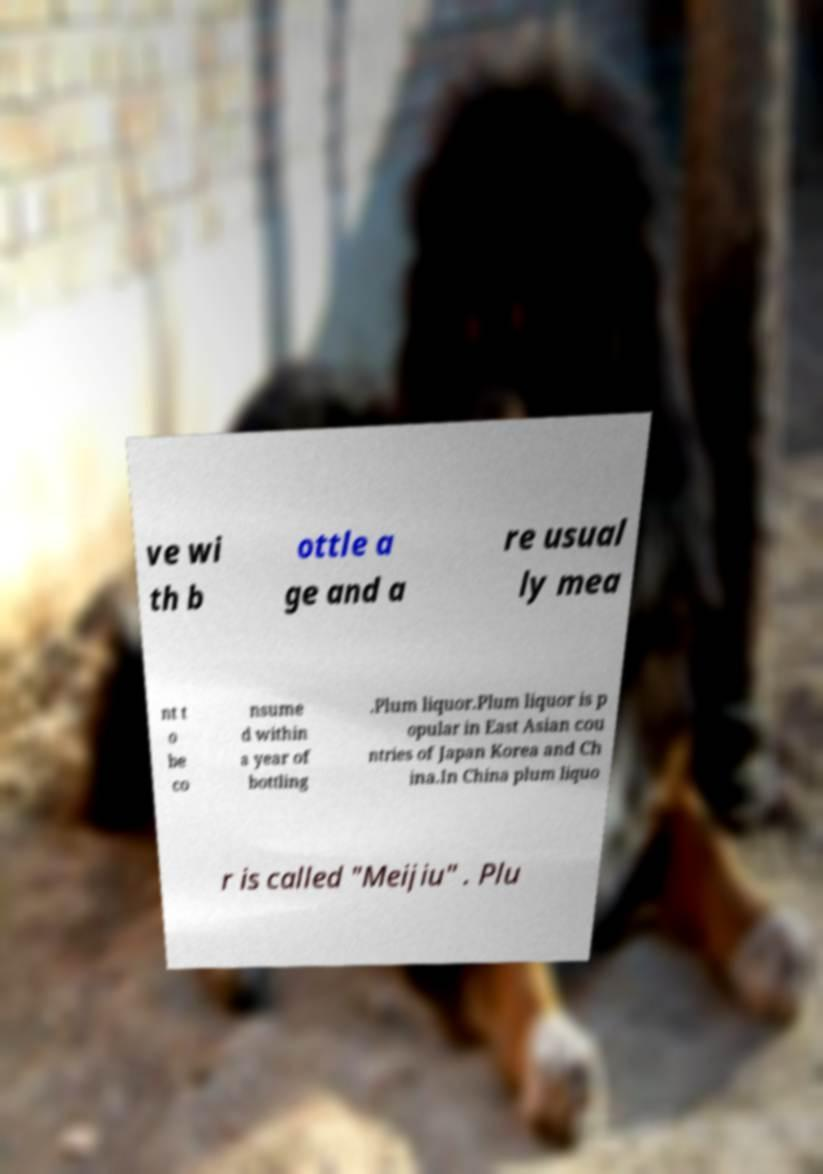Can you accurately transcribe the text from the provided image for me? ve wi th b ottle a ge and a re usual ly mea nt t o be co nsume d within a year of bottling .Plum liquor.Plum liquor is p opular in East Asian cou ntries of Japan Korea and Ch ina.In China plum liquo r is called "Meijiu" . Plu 